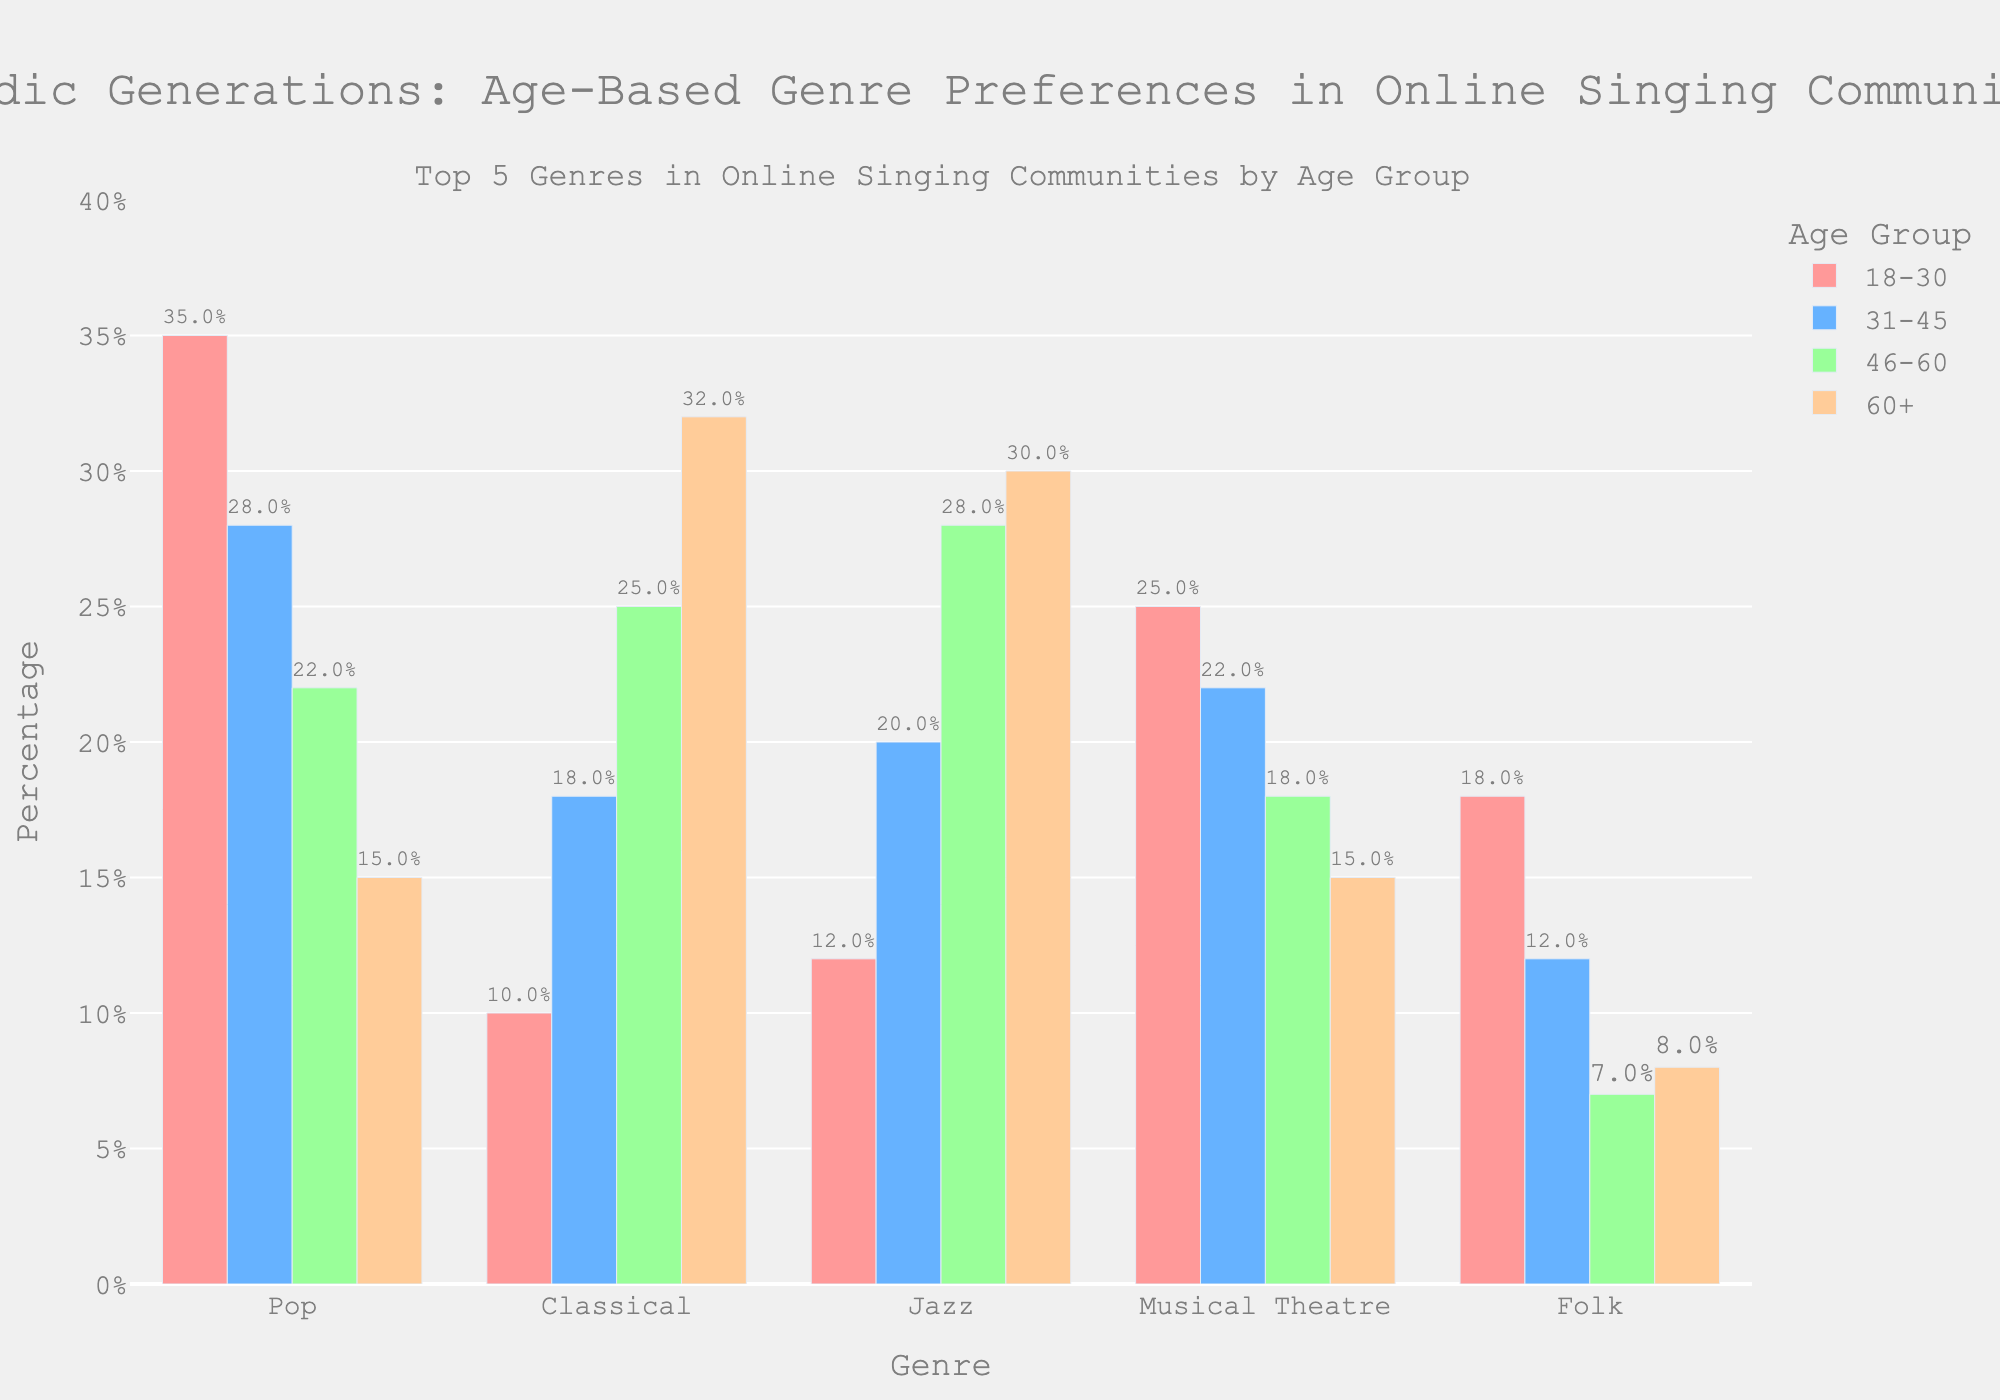What genre is most popular among the 18-30 age group? The highest bar in the 18-30 age group is for Pop, with a percentage of 35%.
Answer: Pop Which age group has the highest percentage of members performing Classical? The highest bar for Classical is in the 60+ age group, with a percentage of 32%.
Answer: 60+ Compare the popularity of Folk music between the 18-30 and 60+ age groups. Which group has a higher percentage, and by how much? The 18-30 age group has an 18% Folk music participation rate, while the 60+ age group has 8%. The difference is 18% - 8% = 10%.
Answer: 18-30, by 10% What is the least popular genre among the 31-45 age group? The shortest bar for the 31-45 age group is for Folk, with a percentage of 12%.
Answer: Folk Calculate the average percentage of members performing Musical Theatre across all age groups. The percentages for Musical Theatre are 25%, 22%, 18%, and 15%. The average is (25 + 22 + 18 + 15) / 4 = 20%.
Answer: 20% Which two genres are most popular among the 46-60 age group? The two highest bars for the 46-60 age group are Jazz (28%) and Classical (25%).
Answer: Jazz and Classical Among the 60+ age group, compare the popularity of Pop and Jazz. Which genre is more popular, and by how much? The Pop participation rate is 15% and Jazz is 30%. The difference is 30% - 15% = 15%.
Answer: Jazz, by 15% What is the combined percentage of members performing Pop and Musical Theatre in the 31-45 age group? The percentages for Pop and Musical Theatre in the 31-45 age group are 28% and 22%, respectively. The combined percentage is 28% + 22% = 50%.
Answer: 50% 